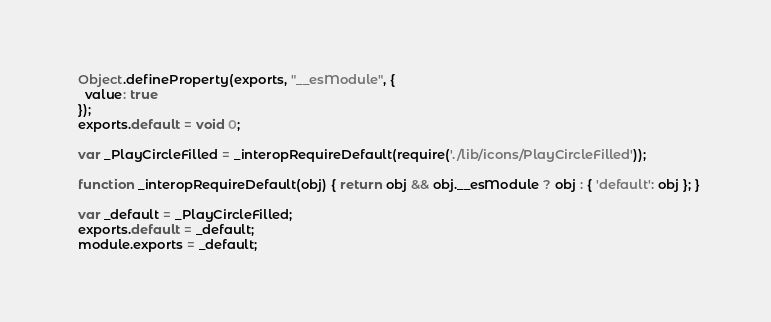<code> <loc_0><loc_0><loc_500><loc_500><_JavaScript_>  Object.defineProperty(exports, "__esModule", {
    value: true
  });
  exports.default = void 0;
  
  var _PlayCircleFilled = _interopRequireDefault(require('./lib/icons/PlayCircleFilled'));
  
  function _interopRequireDefault(obj) { return obj && obj.__esModule ? obj : { 'default': obj }; }
  
  var _default = _PlayCircleFilled;
  exports.default = _default;
  module.exports = _default;</code> 